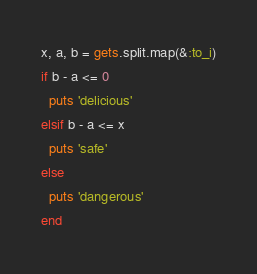<code> <loc_0><loc_0><loc_500><loc_500><_Ruby_>x, a, b = gets.split.map(&:to_i)
if b - a <= 0
  puts 'delicious'
elsif b - a <= x
  puts 'safe'
else
  puts 'dangerous'
end</code> 